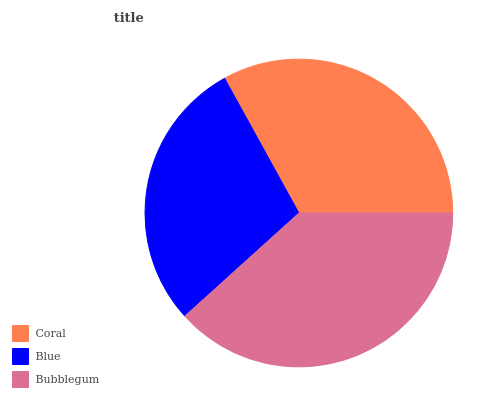Is Blue the minimum?
Answer yes or no. Yes. Is Bubblegum the maximum?
Answer yes or no. Yes. Is Bubblegum the minimum?
Answer yes or no. No. Is Blue the maximum?
Answer yes or no. No. Is Bubblegum greater than Blue?
Answer yes or no. Yes. Is Blue less than Bubblegum?
Answer yes or no. Yes. Is Blue greater than Bubblegum?
Answer yes or no. No. Is Bubblegum less than Blue?
Answer yes or no. No. Is Coral the high median?
Answer yes or no. Yes. Is Coral the low median?
Answer yes or no. Yes. Is Blue the high median?
Answer yes or no. No. Is Blue the low median?
Answer yes or no. No. 